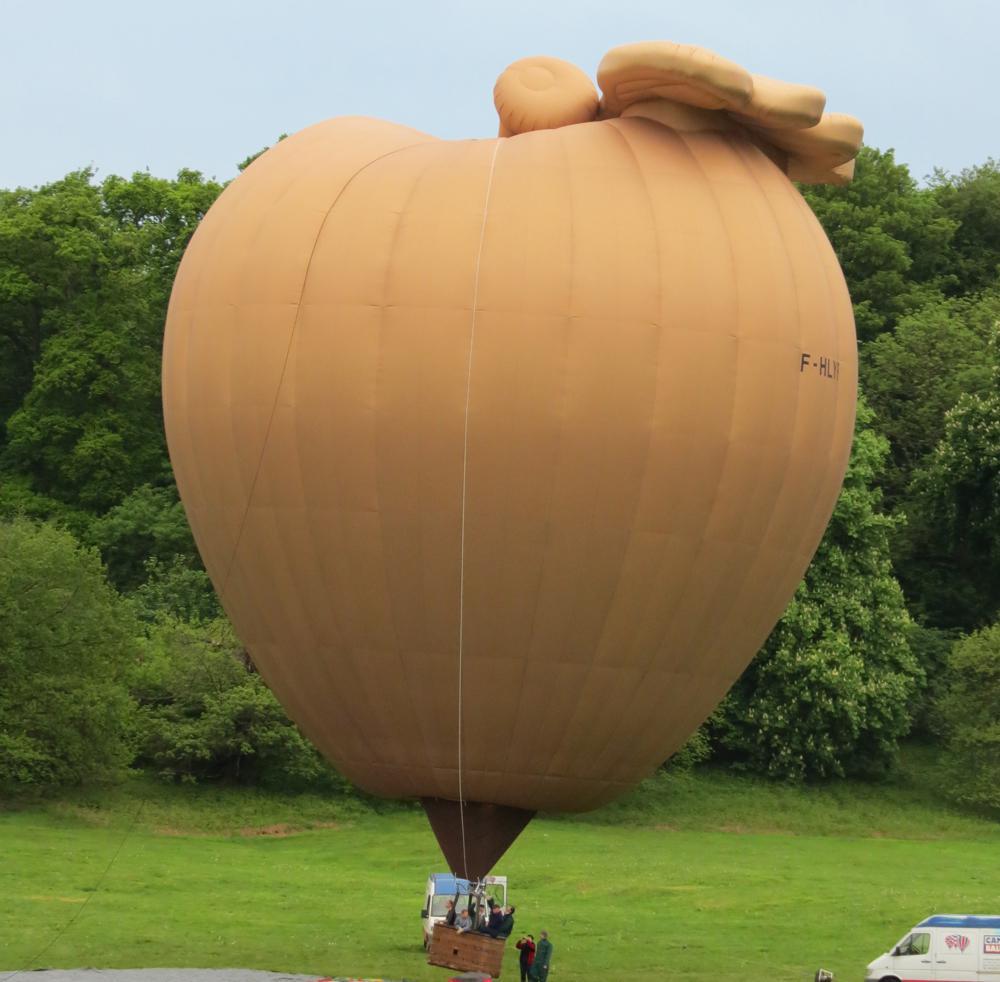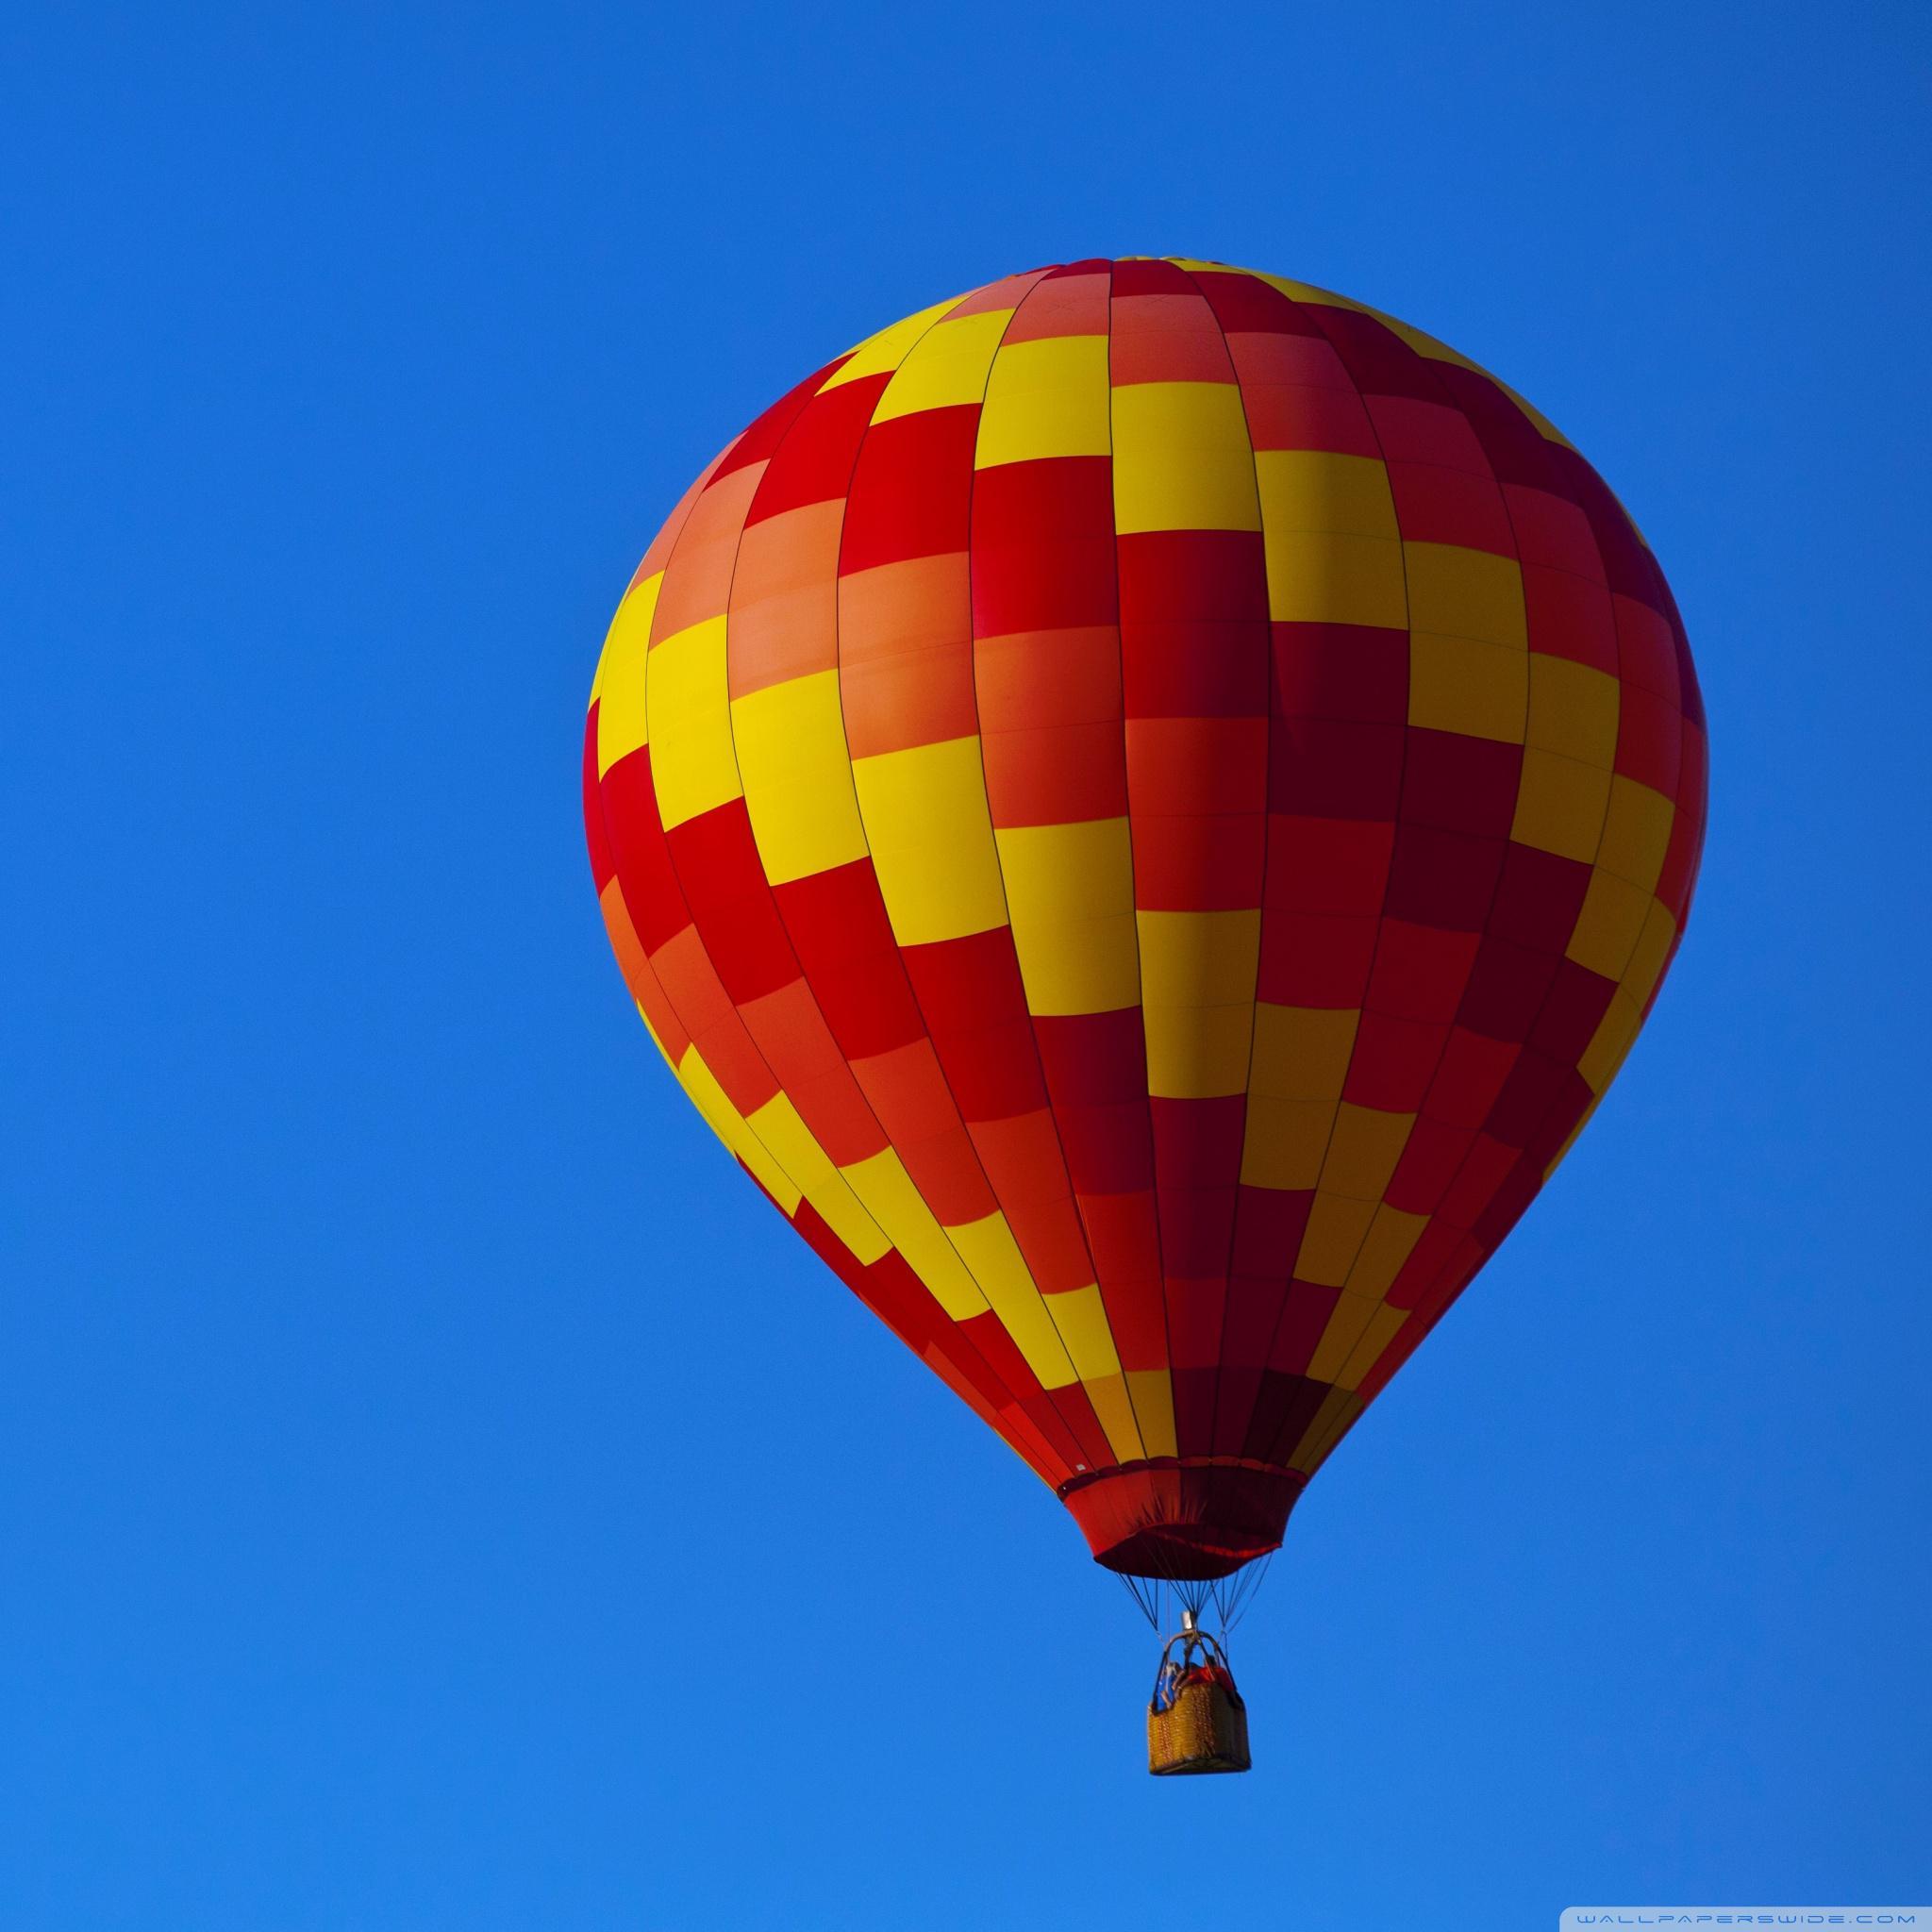The first image is the image on the left, the second image is the image on the right. Assess this claim about the two images: "One hot air balloon is on the ground and one is in the air.". Correct or not? Answer yes or no. Yes. The first image is the image on the left, the second image is the image on the right. Analyze the images presented: Is the assertion "The left image balloon is supposed to look like a red apple." valid? Answer yes or no. No. 